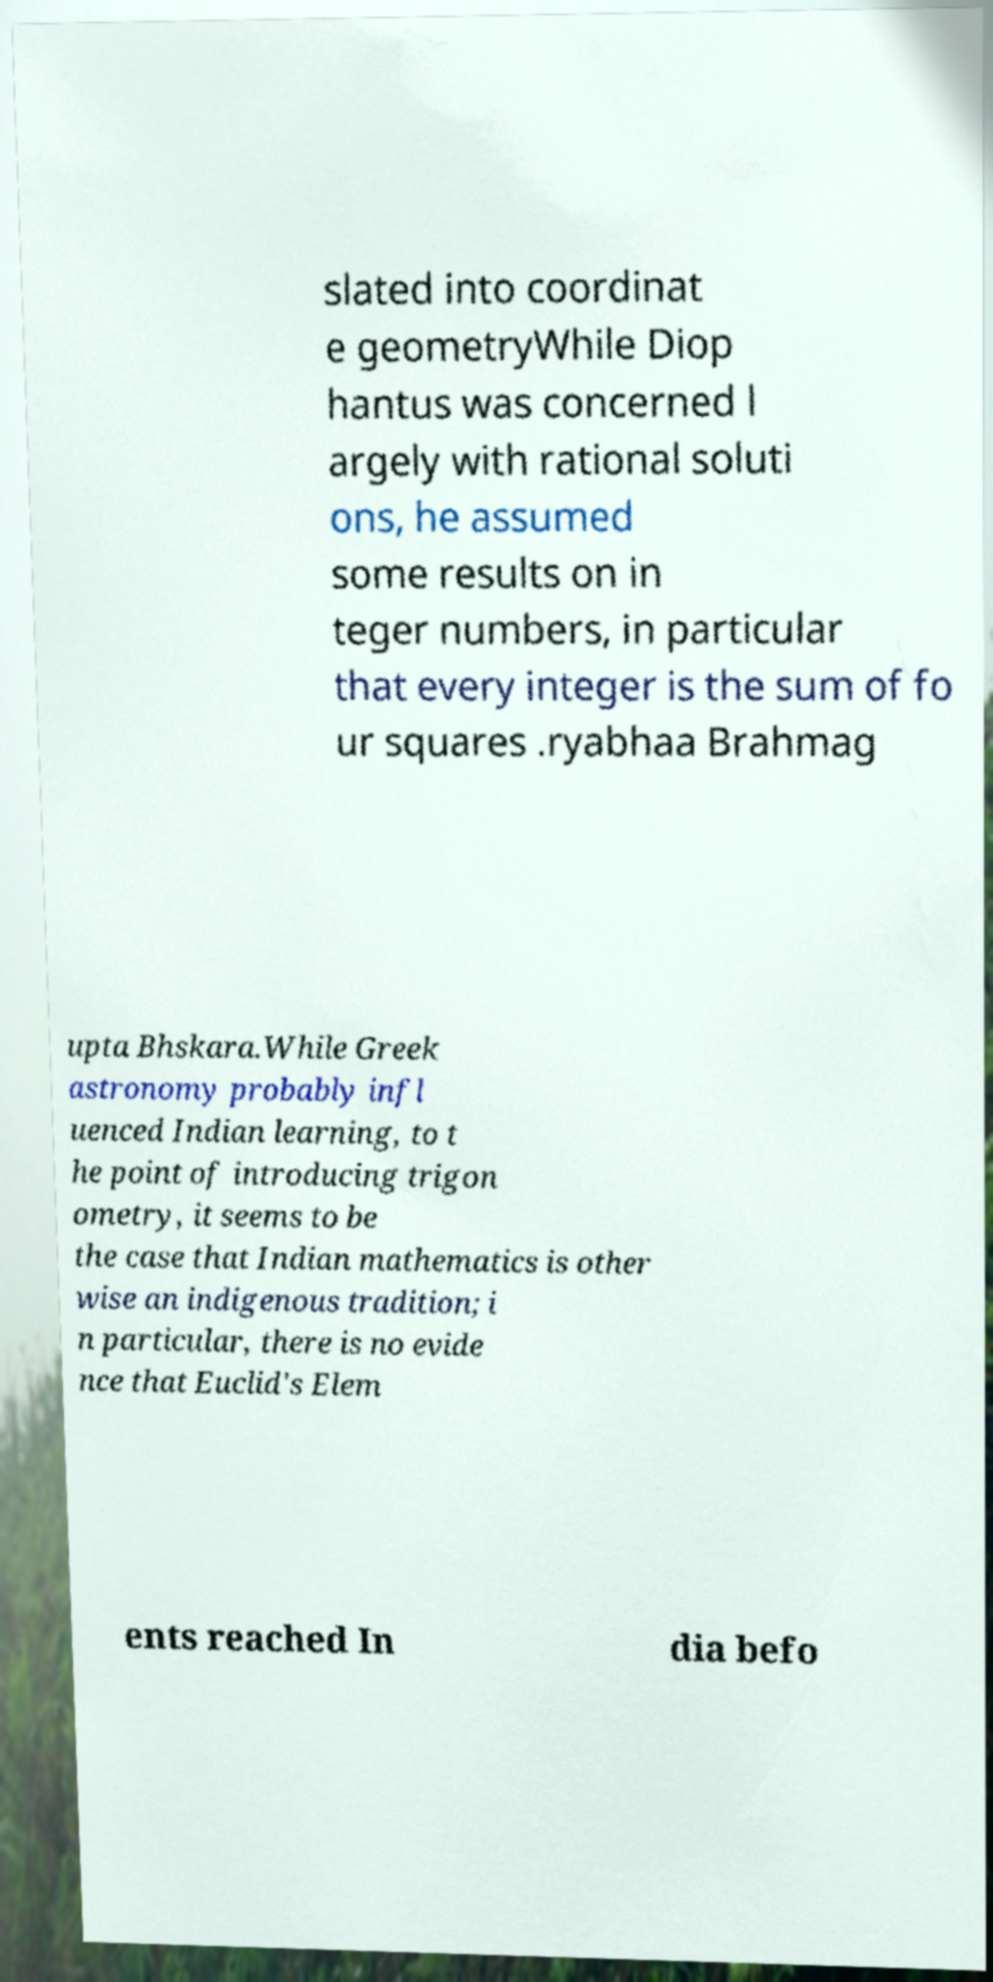Please identify and transcribe the text found in this image. slated into coordinat e geometryWhile Diop hantus was concerned l argely with rational soluti ons, he assumed some results on in teger numbers, in particular that every integer is the sum of fo ur squares .ryabhaa Brahmag upta Bhskara.While Greek astronomy probably infl uenced Indian learning, to t he point of introducing trigon ometry, it seems to be the case that Indian mathematics is other wise an indigenous tradition; i n particular, there is no evide nce that Euclid's Elem ents reached In dia befo 